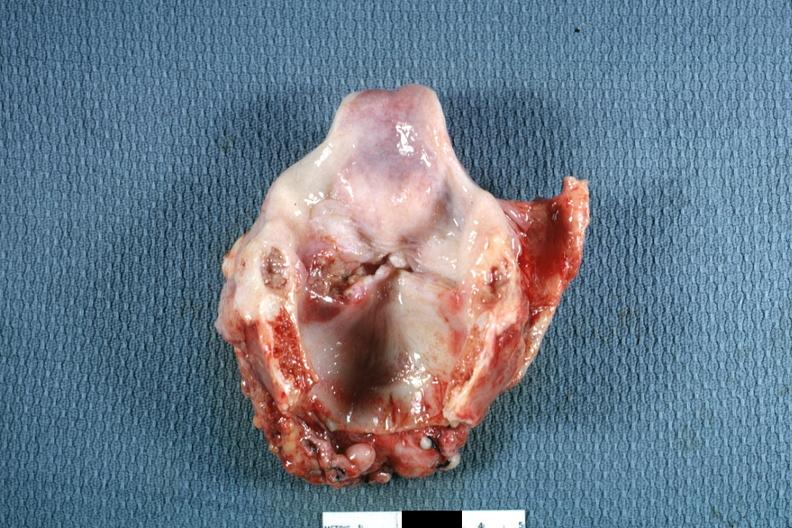how is ulcerative lesion left true cord?
Answer the question using a single word or phrase. Good 